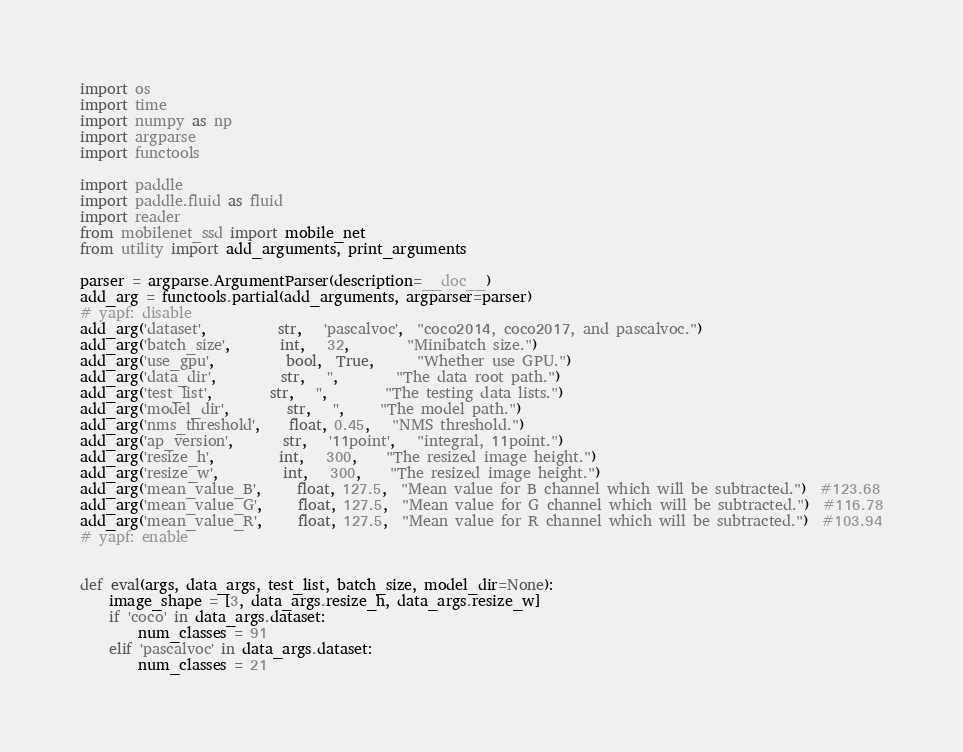Convert code to text. <code><loc_0><loc_0><loc_500><loc_500><_Python_>import os
import time
import numpy as np
import argparse
import functools

import paddle
import paddle.fluid as fluid
import reader
from mobilenet_ssd import mobile_net
from utility import add_arguments, print_arguments

parser = argparse.ArgumentParser(description=__doc__)
add_arg = functools.partial(add_arguments, argparser=parser)
# yapf: disable
add_arg('dataset',          str,   'pascalvoc',  "coco2014, coco2017, and pascalvoc.")
add_arg('batch_size',       int,   32,        "Minibatch size.")
add_arg('use_gpu',          bool,  True,      "Whether use GPU.")
add_arg('data_dir',         str,   '',        "The data root path.")
add_arg('test_list',        str,   '',        "The testing data lists.")
add_arg('model_dir',        str,   '',     "The model path.")
add_arg('nms_threshold',    float, 0.45,   "NMS threshold.")
add_arg('ap_version',       str,   '11point',   "integral, 11point.")
add_arg('resize_h',         int,   300,    "The resized image height.")
add_arg('resize_w',         int,   300,    "The resized image height.")
add_arg('mean_value_B',     float, 127.5,  "Mean value for B channel which will be subtracted.")  #123.68
add_arg('mean_value_G',     float, 127.5,  "Mean value for G channel which will be subtracted.")  #116.78
add_arg('mean_value_R',     float, 127.5,  "Mean value for R channel which will be subtracted.")  #103.94
# yapf: enable


def eval(args, data_args, test_list, batch_size, model_dir=None):
    image_shape = [3, data_args.resize_h, data_args.resize_w]
    if 'coco' in data_args.dataset:
        num_classes = 91
    elif 'pascalvoc' in data_args.dataset:
        num_classes = 21
</code> 